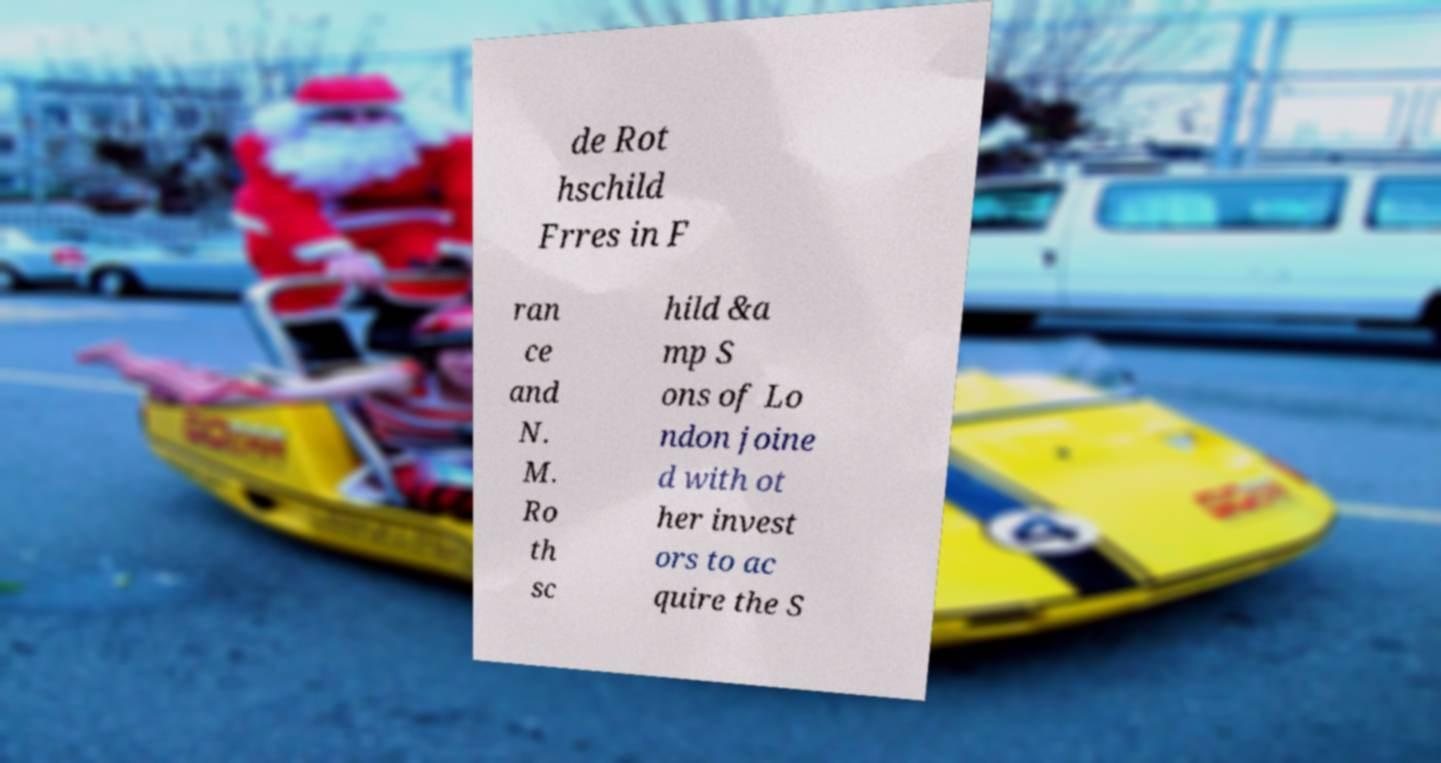Please identify and transcribe the text found in this image. de Rot hschild Frres in F ran ce and N. M. Ro th sc hild &a mp S ons of Lo ndon joine d with ot her invest ors to ac quire the S 